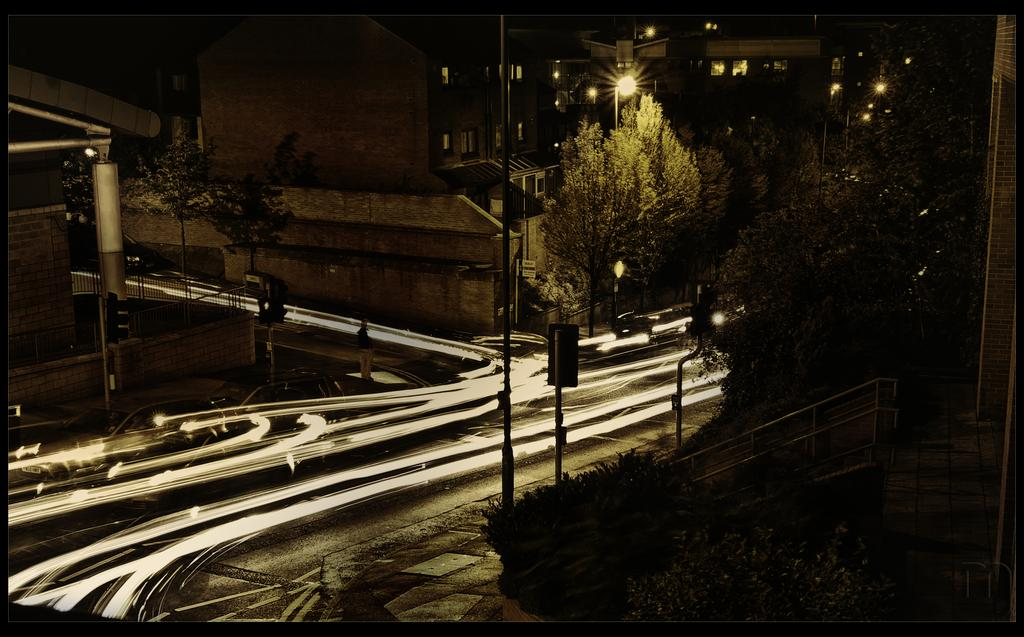What type of natural elements can be seen in the image? There are trees in the image. What type of man-made structures are present in the image? There are poles, roads, lights, vehicles, and buildings with windows in the image. Can you describe the objects in the image? There are some objects in the image. What is the color of the background in the image? The background is dark. What type of army is depicted in the image? There is no army present in the image. What type of joke can be seen in the image? There is no joke present in the image. 